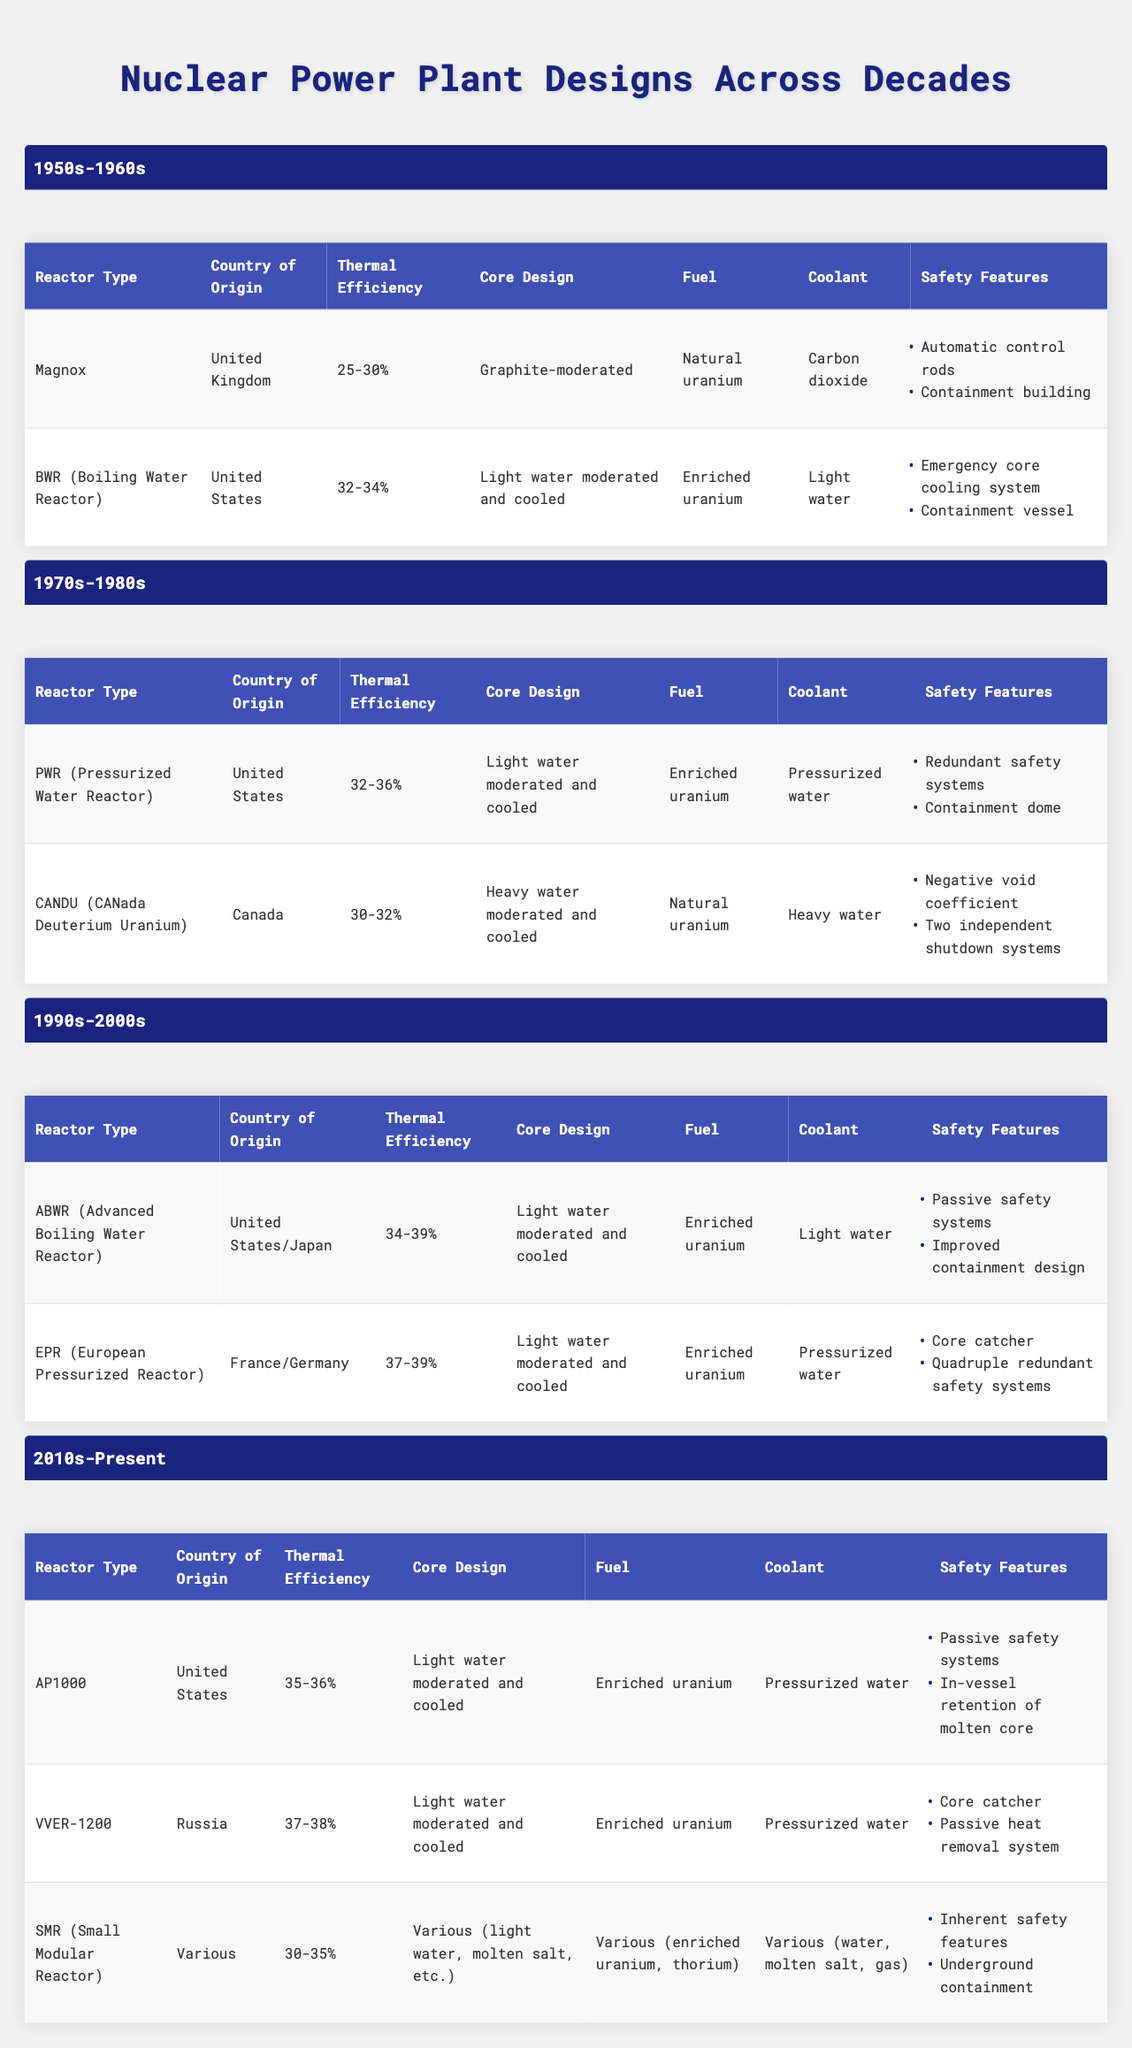What is the thermal efficiency range of Magnox reactors? The table lists the thermal efficiency of Magnox reactors as "25-30%". This value is taken directly from the "Thermal Efficiency" column under the "1950s-1960s" era for the Magnox reactor type.
Answer: 25-30% Which reactor type has the highest thermal efficiency in the 1990s-2000s era? In the 1990s-2000s section, the "EPR" (European Pressurized Reactor) has a thermal efficiency range of "37-39%", which is higher than "34-39%" of the "ABWR". Therefore, the EPR has the highest thermal efficiency.
Answer: EPR (European Pressurized Reactor) Which reactor from the 1970s-1980s era uses heavy water as a coolant? The table indicates that the "CANDU" (CANada Deuterium Uranium) reactor uses heavy water as its coolant. This information is found in the "Coolant" column of the "CANDU" row.
Answer: CANDU Is the fuel type for the AP1000 reactor enriched uranium? The table states that AP1000 has "Enriched uranium" as its fuel type in the "Fuel" column corresponding to the 2010s-Present era. Thus, the fact is true.
Answer: Yes What is the average thermal efficiency of reactors from the 1950s-1960s? The thermal efficiencies provided are "25-30%" for Magnox and "32-34%" for BWR. To average, we consider the midpoints: (27.5 + 33) / 2 = 30.25%. Therefore, the average thermal efficiency is 30.25%.
Answer: 30.25% How many reactor types listed from the 2010s-Present era have passive safety systems? The AP1000 and VVER-1200 both mention "Passive safety systems" in their safety features, which means there are two reactor types with this feature.
Answer: 2 Which era shows an increase in thermal efficiency for reactor types compared to the previous era? The transition from the 1990s-2000s to the 2010s-Present shows that the lowest thermal efficiency increased from "34%" (ABWR) to "35%" (AP1000), indicating a general upward trend in thermal efficiencies across those eras.
Answer: Yes What are the safety features of the VVER-1200 reactor? The safety features of the VVER-1200, as per the table, are "Core catcher" and "Passive heat removal system". These details are directly cited in the safety features list for that reactor type.
Answer: Core catcher; Passive heat removal system Which reactor type features the lowest thermal efficiency among those listed from the 2010s-Present? The SMR (Small Modular Reactor) is listed with a thermal efficiency range of "30-35%", making it the lowest in comparison to other reactors of that era which have higher thermal efficiency ranges.
Answer: SMR (Small Modular Reactor) What is the primary coolant used in BWR reactors? The BWR (Boiling Water Reactor) is stated to use "Light water" as its coolant according to the information presented in the table under the 1950s-1960s era.
Answer: Light water 